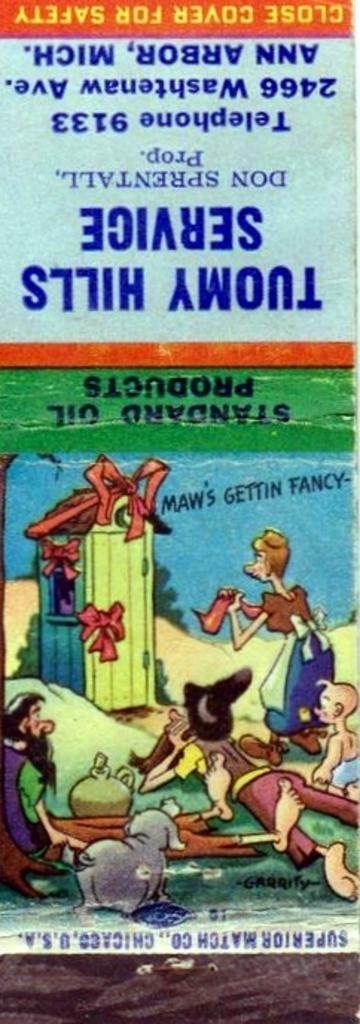<image>
Render a clear and concise summary of the photo. A cartoon depicting hillbillies decorates a product package from Standard Oil Products. 